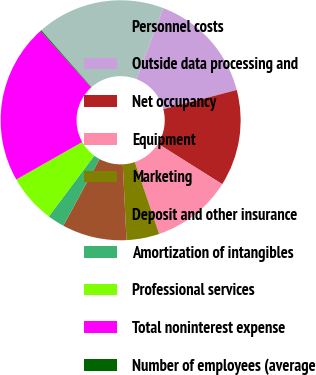Convert chart to OTSL. <chart><loc_0><loc_0><loc_500><loc_500><pie_chart><fcel>Personnel costs<fcel>Outside data processing and<fcel>Net occupancy<fcel>Equipment<fcel>Marketing<fcel>Deposit and other insurance<fcel>Amortization of intangibles<fcel>Professional services<fcel>Total noninterest expense<fcel>Number of employees (average<nl><fcel>17.29%<fcel>15.15%<fcel>13.0%<fcel>10.86%<fcel>4.42%<fcel>8.71%<fcel>2.28%<fcel>6.57%<fcel>21.58%<fcel>0.14%<nl></chart> 